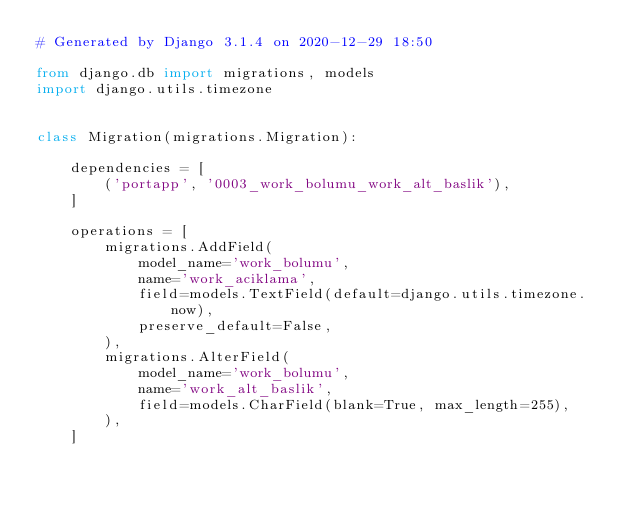Convert code to text. <code><loc_0><loc_0><loc_500><loc_500><_Python_># Generated by Django 3.1.4 on 2020-12-29 18:50

from django.db import migrations, models
import django.utils.timezone


class Migration(migrations.Migration):

    dependencies = [
        ('portapp', '0003_work_bolumu_work_alt_baslik'),
    ]

    operations = [
        migrations.AddField(
            model_name='work_bolumu',
            name='work_aciklama',
            field=models.TextField(default=django.utils.timezone.now),
            preserve_default=False,
        ),
        migrations.AlterField(
            model_name='work_bolumu',
            name='work_alt_baslik',
            field=models.CharField(blank=True, max_length=255),
        ),
    ]
</code> 